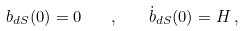Convert formula to latex. <formula><loc_0><loc_0><loc_500><loc_500>b _ { d S } ( 0 ) = 0 \quad , \quad \dot { b } _ { d S } ( 0 ) = H \, ,</formula> 